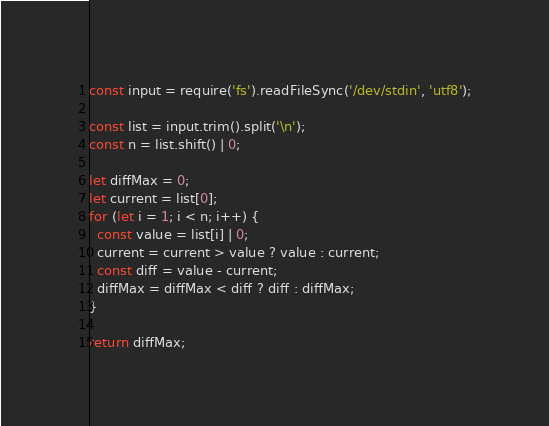Convert code to text. <code><loc_0><loc_0><loc_500><loc_500><_JavaScript_>const input = require('fs').readFileSync('/dev/stdin', 'utf8');

const list = input.trim().split('\n');
const n = list.shift() | 0;

let diffMax = 0;
let current = list[0];
for (let i = 1; i < n; i++) {
  const value = list[i] | 0;
  current = current > value ? value : current;
  const diff = value - current;
  diffMax = diffMax < diff ? diff : diffMax;
}

return diffMax;
</code> 